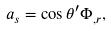<formula> <loc_0><loc_0><loc_500><loc_500>a _ { s } = \cos \theta ^ { \prime } \Phi _ { , r } ,</formula> 